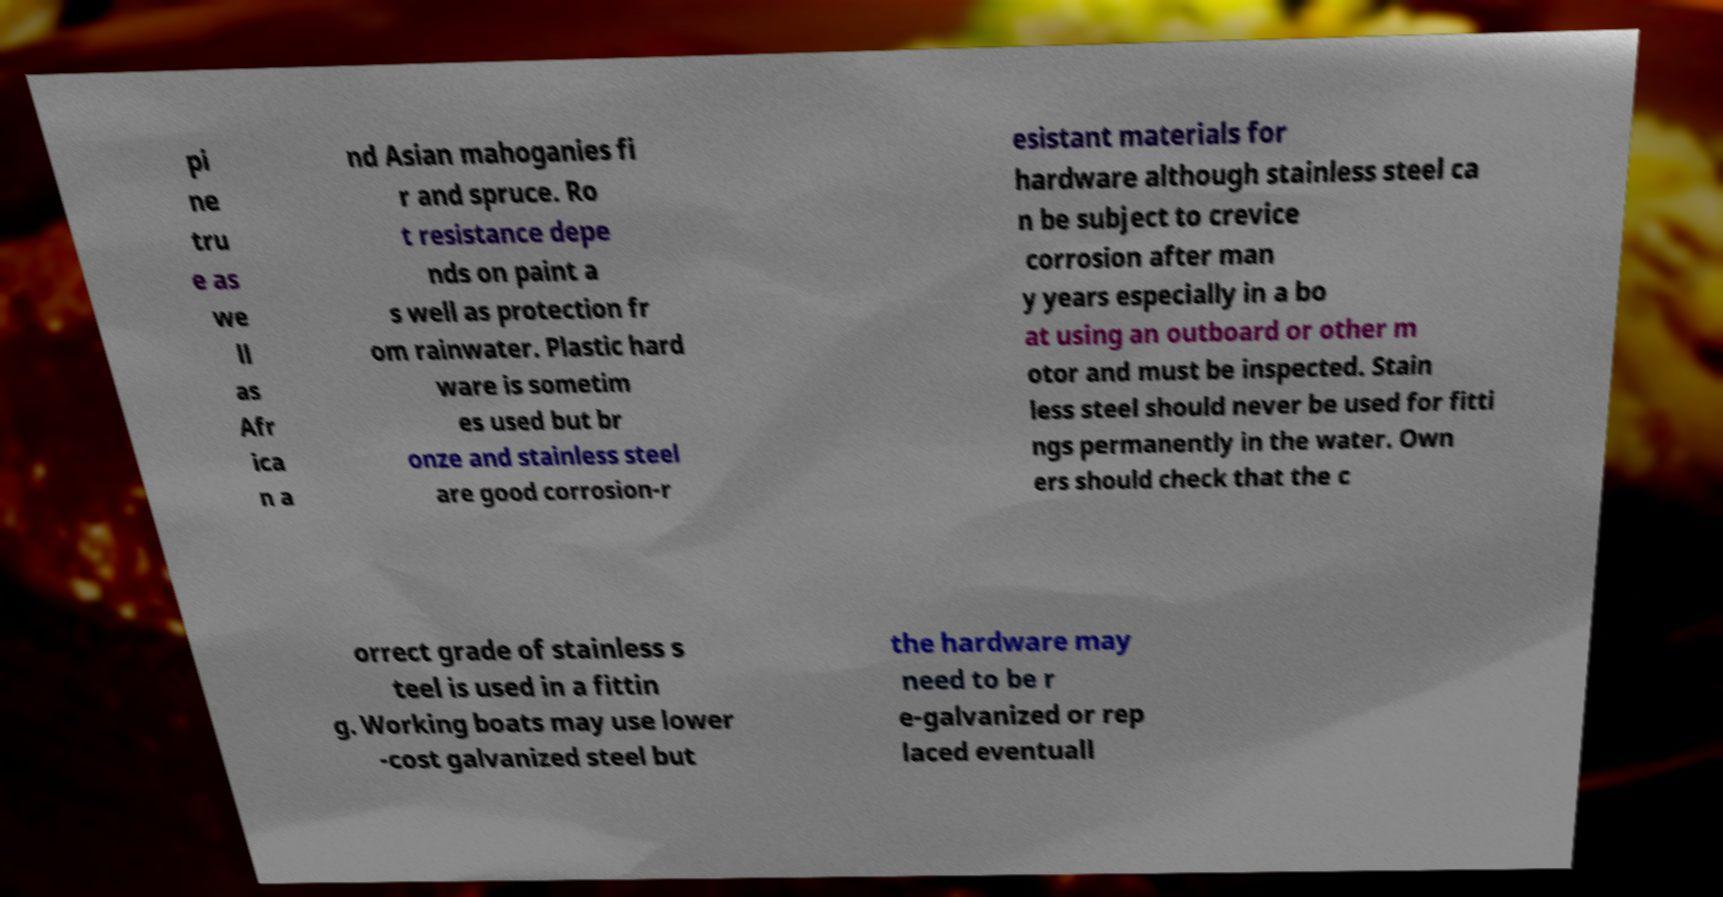Could you extract and type out the text from this image? pi ne tru e as we ll as Afr ica n a nd Asian mahoganies fi r and spruce. Ro t resistance depe nds on paint a s well as protection fr om rainwater. Plastic hard ware is sometim es used but br onze and stainless steel are good corrosion-r esistant materials for hardware although stainless steel ca n be subject to crevice corrosion after man y years especially in a bo at using an outboard or other m otor and must be inspected. Stain less steel should never be used for fitti ngs permanently in the water. Own ers should check that the c orrect grade of stainless s teel is used in a fittin g. Working boats may use lower -cost galvanized steel but the hardware may need to be r e-galvanized or rep laced eventuall 